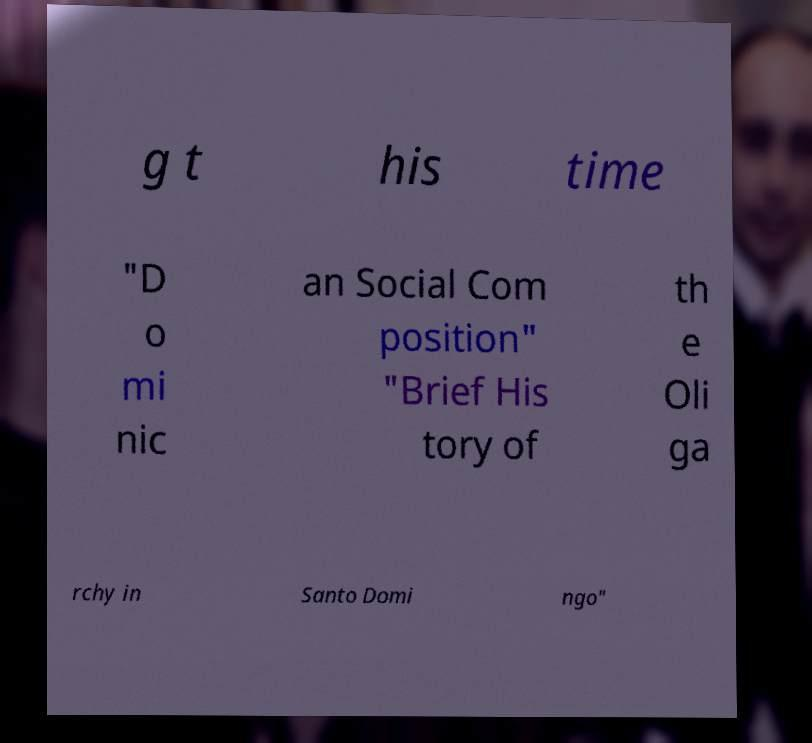Can you read and provide the text displayed in the image?This photo seems to have some interesting text. Can you extract and type it out for me? g t his time "D o mi nic an Social Com position" "Brief His tory of th e Oli ga rchy in Santo Domi ngo" 